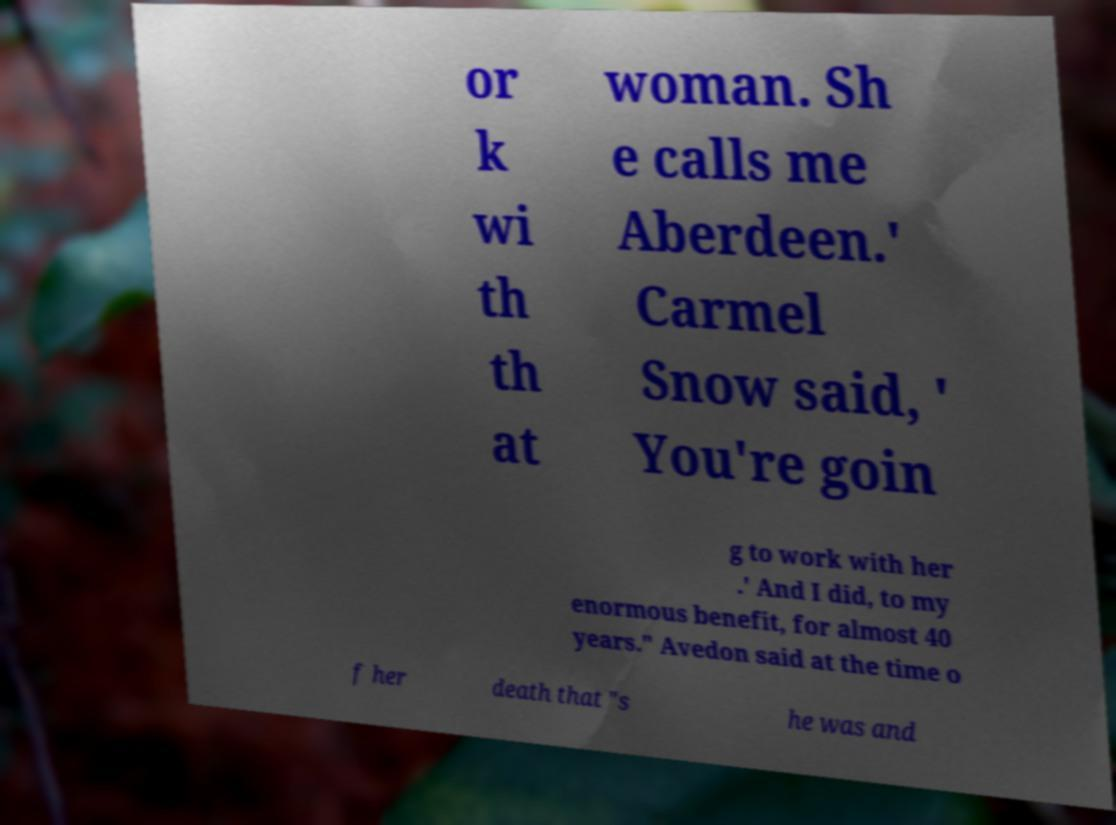Please identify and transcribe the text found in this image. or k wi th th at woman. Sh e calls me Aberdeen.' Carmel Snow said, ' You're goin g to work with her .' And I did, to my enormous benefit, for almost 40 years." Avedon said at the time o f her death that "s he was and 